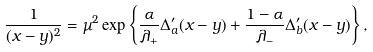Convert formula to latex. <formula><loc_0><loc_0><loc_500><loc_500>\frac { 1 } { ( x - y ) ^ { 2 } } = \mu ^ { 2 } \exp \left \{ \frac { \alpha } { \lambda _ { + } } \Delta _ { a } ^ { \prime } ( x - y ) + \frac { 1 - \alpha } { \lambda _ { - } } \Delta _ { b } ^ { \prime } ( x - y ) \right \} ,</formula> 